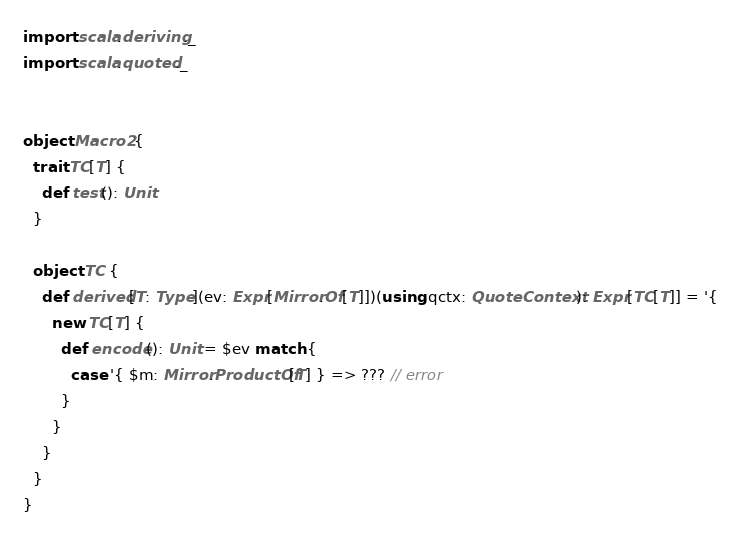<code> <loc_0><loc_0><loc_500><loc_500><_Scala_>import scala.deriving._
import scala.quoted._


object Macro2 {
  trait TC[T] {
    def test(): Unit
  }

  object TC {
    def derived[T: Type](ev: Expr[Mirror.Of[T]])(using qctx: QuoteContext): Expr[TC[T]] = '{
      new TC[T] {
        def encode(): Unit = $ev match {
          case '{ $m: Mirror.ProductOf[T] } => ??? // error
        }
      }
    }
  }
}
</code> 